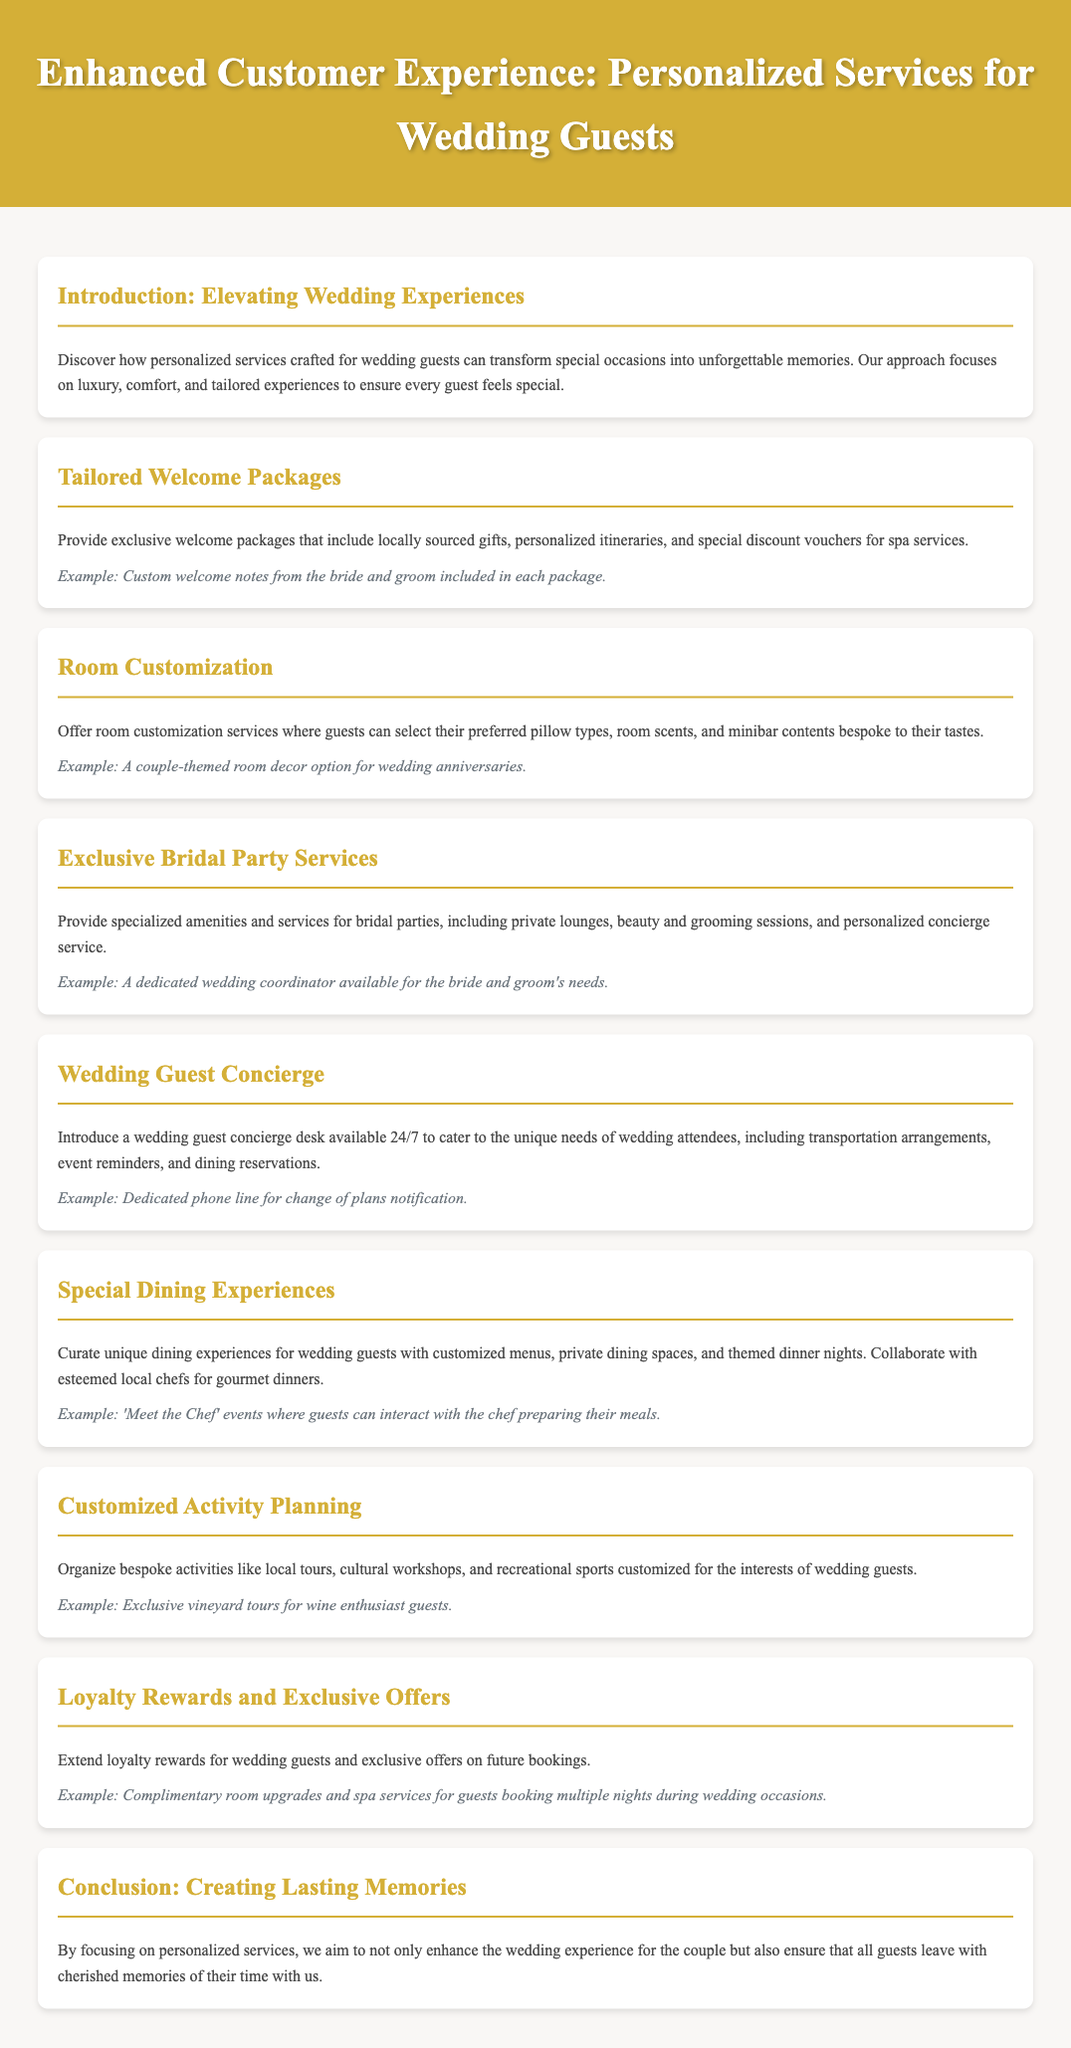What is the title of the document? The title is prominently displayed at the top of the document.
Answer: Enhanced Customer Experience: Personalized Services for Wedding Guests What is included in the tailored welcome packages? The document specifies components of the welcome packages under the relevant section.
Answer: Locally sourced gifts, personalized itineraries, and special discount vouchers for spa services What service is dedicated to the bridal party? This section highlights a specific service offered to attend to the bridal party's needs.
Answer: Specialized amenities and services What types of dining experiences are provided for guests? The document outlines the unique dining experiences planned for wedding guests.
Answer: Customized menus, private dining spaces, and themed dinner nights Which additional service can guests expect for activity planning? The document details the kind of services provided for activity planning tailored for guests.
Answer: Bespoke activities like local tours, cultural workshops, and recreational sports What is a feature of the wedding guest concierge service? The description of the concierge service outlines its functionalities regarding guest assistance.
Answer: Available 24/7 How can wedding guests benefit from loyalty rewards? The document specifies particular benefits offered as part of the loyalty rewards program.
Answer: Complimentary room upgrades and spa services What is the aim of personalized services as mentioned in the conclusion? The concluding section articulates the purpose behind the personalized services.
Answer: To create lasting memories 